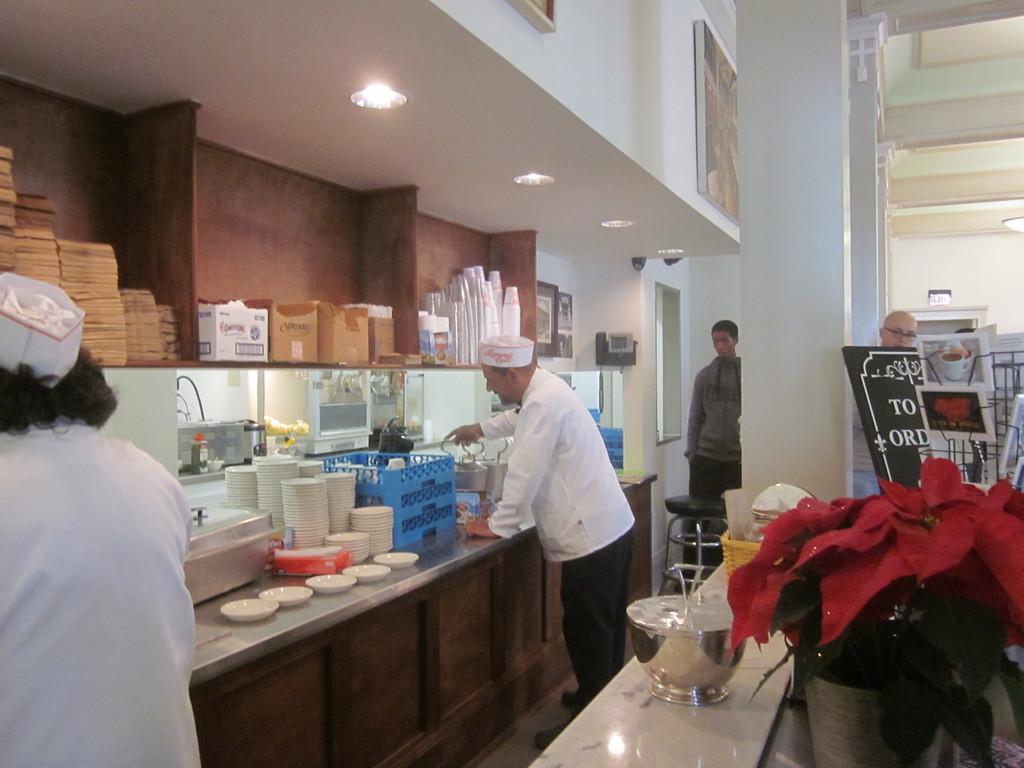How would you summarize this image in a sentence or two? In this image there are persons standing and there are cutleries, there are boxes, there are flowers, there are frames on the wall and is a board with some text written on it and there are objects which are blue in colour. 